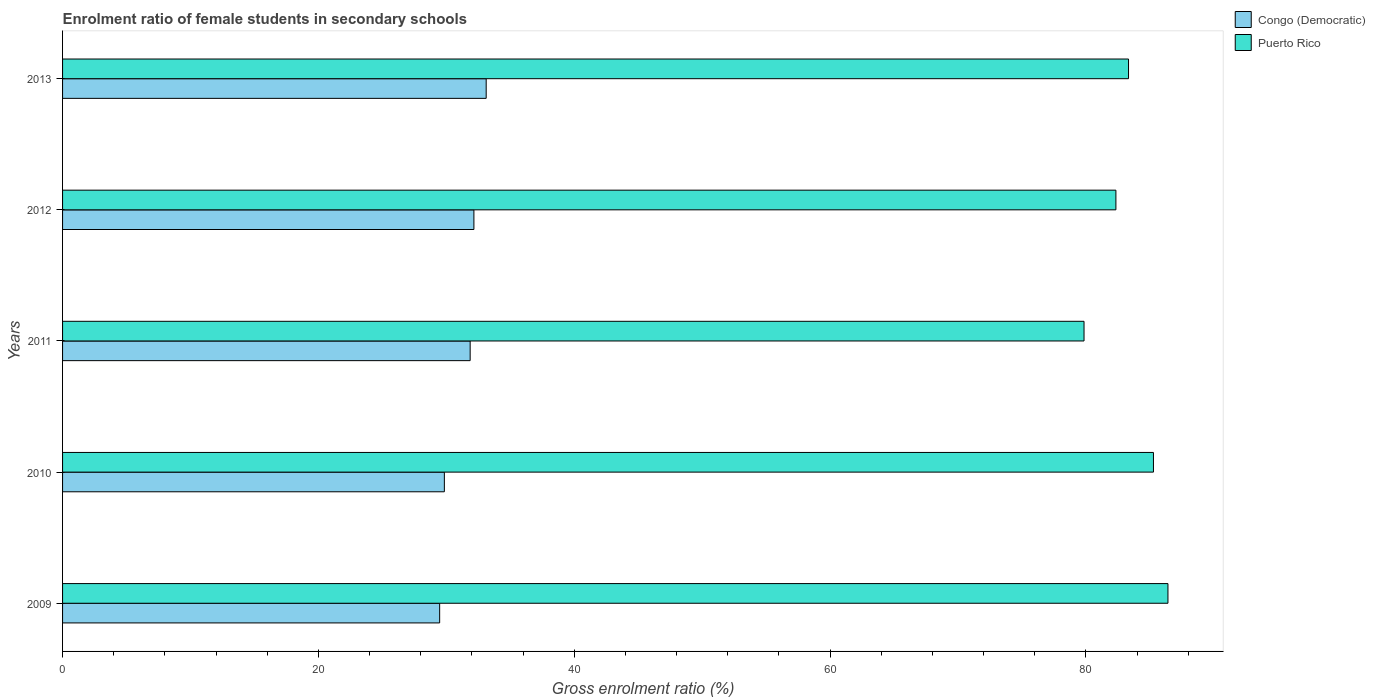How many groups of bars are there?
Offer a very short reply. 5. Are the number of bars per tick equal to the number of legend labels?
Keep it short and to the point. Yes. How many bars are there on the 1st tick from the top?
Your answer should be very brief. 2. How many bars are there on the 3rd tick from the bottom?
Your response must be concise. 2. What is the enrolment ratio of female students in secondary schools in Puerto Rico in 2010?
Your answer should be very brief. 85.28. Across all years, what is the maximum enrolment ratio of female students in secondary schools in Congo (Democratic)?
Provide a short and direct response. 33.12. Across all years, what is the minimum enrolment ratio of female students in secondary schools in Congo (Democratic)?
Offer a very short reply. 29.48. What is the total enrolment ratio of female students in secondary schools in Congo (Democratic) in the graph?
Make the answer very short. 156.47. What is the difference between the enrolment ratio of female students in secondary schools in Puerto Rico in 2010 and that in 2011?
Provide a succinct answer. 5.43. What is the difference between the enrolment ratio of female students in secondary schools in Puerto Rico in 2011 and the enrolment ratio of female students in secondary schools in Congo (Democratic) in 2012?
Your answer should be very brief. 47.7. What is the average enrolment ratio of female students in secondary schools in Puerto Rico per year?
Keep it short and to the point. 83.45. In the year 2012, what is the difference between the enrolment ratio of female students in secondary schools in Congo (Democratic) and enrolment ratio of female students in secondary schools in Puerto Rico?
Your answer should be very brief. -50.19. In how many years, is the enrolment ratio of female students in secondary schools in Congo (Democratic) greater than 44 %?
Provide a succinct answer. 0. What is the ratio of the enrolment ratio of female students in secondary schools in Congo (Democratic) in 2009 to that in 2010?
Give a very brief answer. 0.99. Is the enrolment ratio of female students in secondary schools in Puerto Rico in 2010 less than that in 2011?
Provide a short and direct response. No. What is the difference between the highest and the second highest enrolment ratio of female students in secondary schools in Puerto Rico?
Keep it short and to the point. 1.13. What is the difference between the highest and the lowest enrolment ratio of female students in secondary schools in Puerto Rico?
Keep it short and to the point. 6.56. In how many years, is the enrolment ratio of female students in secondary schools in Congo (Democratic) greater than the average enrolment ratio of female students in secondary schools in Congo (Democratic) taken over all years?
Offer a very short reply. 3. What does the 1st bar from the top in 2009 represents?
Ensure brevity in your answer.  Puerto Rico. What does the 1st bar from the bottom in 2010 represents?
Provide a succinct answer. Congo (Democratic). How many years are there in the graph?
Your response must be concise. 5. Are the values on the major ticks of X-axis written in scientific E-notation?
Your answer should be compact. No. Where does the legend appear in the graph?
Give a very brief answer. Top right. How many legend labels are there?
Make the answer very short. 2. How are the legend labels stacked?
Your response must be concise. Vertical. What is the title of the graph?
Provide a short and direct response. Enrolment ratio of female students in secondary schools. Does "El Salvador" appear as one of the legend labels in the graph?
Your answer should be compact. No. What is the label or title of the X-axis?
Provide a succinct answer. Gross enrolment ratio (%). What is the label or title of the Y-axis?
Your answer should be compact. Years. What is the Gross enrolment ratio (%) of Congo (Democratic) in 2009?
Offer a terse response. 29.48. What is the Gross enrolment ratio (%) in Puerto Rico in 2009?
Your answer should be compact. 86.42. What is the Gross enrolment ratio (%) in Congo (Democratic) in 2010?
Give a very brief answer. 29.85. What is the Gross enrolment ratio (%) of Puerto Rico in 2010?
Make the answer very short. 85.28. What is the Gross enrolment ratio (%) in Congo (Democratic) in 2011?
Offer a terse response. 31.86. What is the Gross enrolment ratio (%) in Puerto Rico in 2011?
Provide a succinct answer. 79.85. What is the Gross enrolment ratio (%) of Congo (Democratic) in 2012?
Your answer should be compact. 32.16. What is the Gross enrolment ratio (%) in Puerto Rico in 2012?
Provide a short and direct response. 82.35. What is the Gross enrolment ratio (%) in Congo (Democratic) in 2013?
Your response must be concise. 33.12. What is the Gross enrolment ratio (%) in Puerto Rico in 2013?
Provide a short and direct response. 83.33. Across all years, what is the maximum Gross enrolment ratio (%) of Congo (Democratic)?
Provide a short and direct response. 33.12. Across all years, what is the maximum Gross enrolment ratio (%) in Puerto Rico?
Ensure brevity in your answer.  86.42. Across all years, what is the minimum Gross enrolment ratio (%) in Congo (Democratic)?
Your answer should be compact. 29.48. Across all years, what is the minimum Gross enrolment ratio (%) of Puerto Rico?
Offer a very short reply. 79.85. What is the total Gross enrolment ratio (%) of Congo (Democratic) in the graph?
Your answer should be compact. 156.47. What is the total Gross enrolment ratio (%) in Puerto Rico in the graph?
Make the answer very short. 417.23. What is the difference between the Gross enrolment ratio (%) of Congo (Democratic) in 2009 and that in 2010?
Offer a terse response. -0.37. What is the difference between the Gross enrolment ratio (%) in Puerto Rico in 2009 and that in 2010?
Make the answer very short. 1.13. What is the difference between the Gross enrolment ratio (%) of Congo (Democratic) in 2009 and that in 2011?
Give a very brief answer. -2.38. What is the difference between the Gross enrolment ratio (%) in Puerto Rico in 2009 and that in 2011?
Give a very brief answer. 6.56. What is the difference between the Gross enrolment ratio (%) in Congo (Democratic) in 2009 and that in 2012?
Keep it short and to the point. -2.68. What is the difference between the Gross enrolment ratio (%) of Puerto Rico in 2009 and that in 2012?
Offer a very short reply. 4.07. What is the difference between the Gross enrolment ratio (%) of Congo (Democratic) in 2009 and that in 2013?
Offer a very short reply. -3.64. What is the difference between the Gross enrolment ratio (%) in Puerto Rico in 2009 and that in 2013?
Make the answer very short. 3.08. What is the difference between the Gross enrolment ratio (%) in Congo (Democratic) in 2010 and that in 2011?
Provide a short and direct response. -2.02. What is the difference between the Gross enrolment ratio (%) in Puerto Rico in 2010 and that in 2011?
Ensure brevity in your answer.  5.43. What is the difference between the Gross enrolment ratio (%) of Congo (Democratic) in 2010 and that in 2012?
Your response must be concise. -2.31. What is the difference between the Gross enrolment ratio (%) in Puerto Rico in 2010 and that in 2012?
Keep it short and to the point. 2.94. What is the difference between the Gross enrolment ratio (%) in Congo (Democratic) in 2010 and that in 2013?
Keep it short and to the point. -3.27. What is the difference between the Gross enrolment ratio (%) of Puerto Rico in 2010 and that in 2013?
Provide a succinct answer. 1.95. What is the difference between the Gross enrolment ratio (%) in Congo (Democratic) in 2011 and that in 2012?
Keep it short and to the point. -0.29. What is the difference between the Gross enrolment ratio (%) in Puerto Rico in 2011 and that in 2012?
Provide a short and direct response. -2.49. What is the difference between the Gross enrolment ratio (%) of Congo (Democratic) in 2011 and that in 2013?
Provide a succinct answer. -1.25. What is the difference between the Gross enrolment ratio (%) of Puerto Rico in 2011 and that in 2013?
Your answer should be very brief. -3.48. What is the difference between the Gross enrolment ratio (%) of Congo (Democratic) in 2012 and that in 2013?
Offer a very short reply. -0.96. What is the difference between the Gross enrolment ratio (%) in Puerto Rico in 2012 and that in 2013?
Make the answer very short. -0.99. What is the difference between the Gross enrolment ratio (%) of Congo (Democratic) in 2009 and the Gross enrolment ratio (%) of Puerto Rico in 2010?
Give a very brief answer. -55.8. What is the difference between the Gross enrolment ratio (%) in Congo (Democratic) in 2009 and the Gross enrolment ratio (%) in Puerto Rico in 2011?
Your answer should be very brief. -50.37. What is the difference between the Gross enrolment ratio (%) of Congo (Democratic) in 2009 and the Gross enrolment ratio (%) of Puerto Rico in 2012?
Provide a succinct answer. -52.87. What is the difference between the Gross enrolment ratio (%) of Congo (Democratic) in 2009 and the Gross enrolment ratio (%) of Puerto Rico in 2013?
Your answer should be compact. -53.85. What is the difference between the Gross enrolment ratio (%) of Congo (Democratic) in 2010 and the Gross enrolment ratio (%) of Puerto Rico in 2011?
Give a very brief answer. -50.01. What is the difference between the Gross enrolment ratio (%) of Congo (Democratic) in 2010 and the Gross enrolment ratio (%) of Puerto Rico in 2012?
Give a very brief answer. -52.5. What is the difference between the Gross enrolment ratio (%) in Congo (Democratic) in 2010 and the Gross enrolment ratio (%) in Puerto Rico in 2013?
Your answer should be compact. -53.49. What is the difference between the Gross enrolment ratio (%) of Congo (Democratic) in 2011 and the Gross enrolment ratio (%) of Puerto Rico in 2012?
Give a very brief answer. -50.48. What is the difference between the Gross enrolment ratio (%) of Congo (Democratic) in 2011 and the Gross enrolment ratio (%) of Puerto Rico in 2013?
Keep it short and to the point. -51.47. What is the difference between the Gross enrolment ratio (%) of Congo (Democratic) in 2012 and the Gross enrolment ratio (%) of Puerto Rico in 2013?
Your answer should be very brief. -51.18. What is the average Gross enrolment ratio (%) of Congo (Democratic) per year?
Provide a succinct answer. 31.29. What is the average Gross enrolment ratio (%) in Puerto Rico per year?
Make the answer very short. 83.45. In the year 2009, what is the difference between the Gross enrolment ratio (%) in Congo (Democratic) and Gross enrolment ratio (%) in Puerto Rico?
Provide a short and direct response. -56.94. In the year 2010, what is the difference between the Gross enrolment ratio (%) in Congo (Democratic) and Gross enrolment ratio (%) in Puerto Rico?
Your answer should be compact. -55.43. In the year 2011, what is the difference between the Gross enrolment ratio (%) in Congo (Democratic) and Gross enrolment ratio (%) in Puerto Rico?
Your response must be concise. -47.99. In the year 2012, what is the difference between the Gross enrolment ratio (%) of Congo (Democratic) and Gross enrolment ratio (%) of Puerto Rico?
Make the answer very short. -50.19. In the year 2013, what is the difference between the Gross enrolment ratio (%) in Congo (Democratic) and Gross enrolment ratio (%) in Puerto Rico?
Offer a very short reply. -50.22. What is the ratio of the Gross enrolment ratio (%) in Puerto Rico in 2009 to that in 2010?
Provide a short and direct response. 1.01. What is the ratio of the Gross enrolment ratio (%) of Congo (Democratic) in 2009 to that in 2011?
Keep it short and to the point. 0.93. What is the ratio of the Gross enrolment ratio (%) in Puerto Rico in 2009 to that in 2011?
Make the answer very short. 1.08. What is the ratio of the Gross enrolment ratio (%) of Puerto Rico in 2009 to that in 2012?
Your response must be concise. 1.05. What is the ratio of the Gross enrolment ratio (%) of Congo (Democratic) in 2009 to that in 2013?
Give a very brief answer. 0.89. What is the ratio of the Gross enrolment ratio (%) in Congo (Democratic) in 2010 to that in 2011?
Offer a terse response. 0.94. What is the ratio of the Gross enrolment ratio (%) of Puerto Rico in 2010 to that in 2011?
Provide a succinct answer. 1.07. What is the ratio of the Gross enrolment ratio (%) of Congo (Democratic) in 2010 to that in 2012?
Ensure brevity in your answer.  0.93. What is the ratio of the Gross enrolment ratio (%) in Puerto Rico in 2010 to that in 2012?
Offer a terse response. 1.04. What is the ratio of the Gross enrolment ratio (%) in Congo (Democratic) in 2010 to that in 2013?
Your answer should be compact. 0.9. What is the ratio of the Gross enrolment ratio (%) of Puerto Rico in 2010 to that in 2013?
Provide a succinct answer. 1.02. What is the ratio of the Gross enrolment ratio (%) of Congo (Democratic) in 2011 to that in 2012?
Provide a short and direct response. 0.99. What is the ratio of the Gross enrolment ratio (%) in Puerto Rico in 2011 to that in 2012?
Provide a short and direct response. 0.97. What is the ratio of the Gross enrolment ratio (%) of Congo (Democratic) in 2011 to that in 2013?
Offer a very short reply. 0.96. What is the ratio of the Gross enrolment ratio (%) in Puerto Rico in 2011 to that in 2013?
Ensure brevity in your answer.  0.96. What is the ratio of the Gross enrolment ratio (%) of Congo (Democratic) in 2012 to that in 2013?
Your answer should be compact. 0.97. What is the difference between the highest and the second highest Gross enrolment ratio (%) of Congo (Democratic)?
Your answer should be compact. 0.96. What is the difference between the highest and the second highest Gross enrolment ratio (%) in Puerto Rico?
Offer a terse response. 1.13. What is the difference between the highest and the lowest Gross enrolment ratio (%) in Congo (Democratic)?
Ensure brevity in your answer.  3.64. What is the difference between the highest and the lowest Gross enrolment ratio (%) in Puerto Rico?
Your response must be concise. 6.56. 